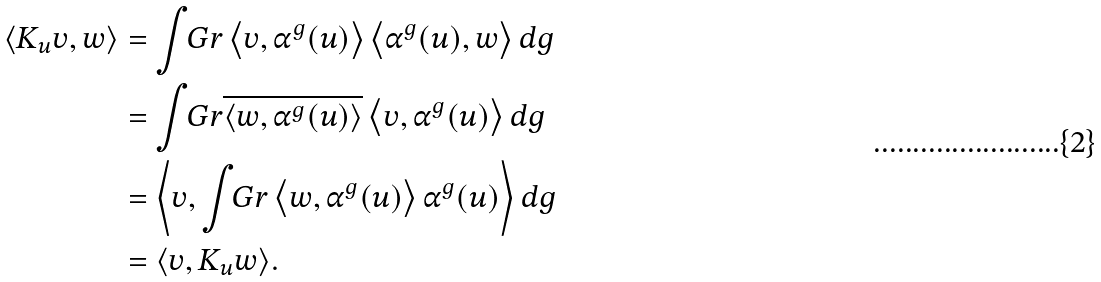<formula> <loc_0><loc_0><loc_500><loc_500>\langle K _ { u } v , w \rangle & = \int _ { \ } G r \left \langle v , \alpha ^ { g } ( u ) \right \rangle \left \langle \alpha ^ { g } ( u ) , w \right \rangle d g \\ & = \int _ { \ } G r \overline { \left \langle w , \alpha ^ { g } ( u ) \right \rangle } \left \langle v , \alpha ^ { g } ( u ) \right \rangle d g \\ & = \left \langle v , \int _ { \ } G r \left \langle w , \alpha ^ { g } ( u ) \right \rangle \alpha ^ { g } ( u ) \right \rangle d g \\ & = \langle v , K _ { u } w \rangle .</formula> 